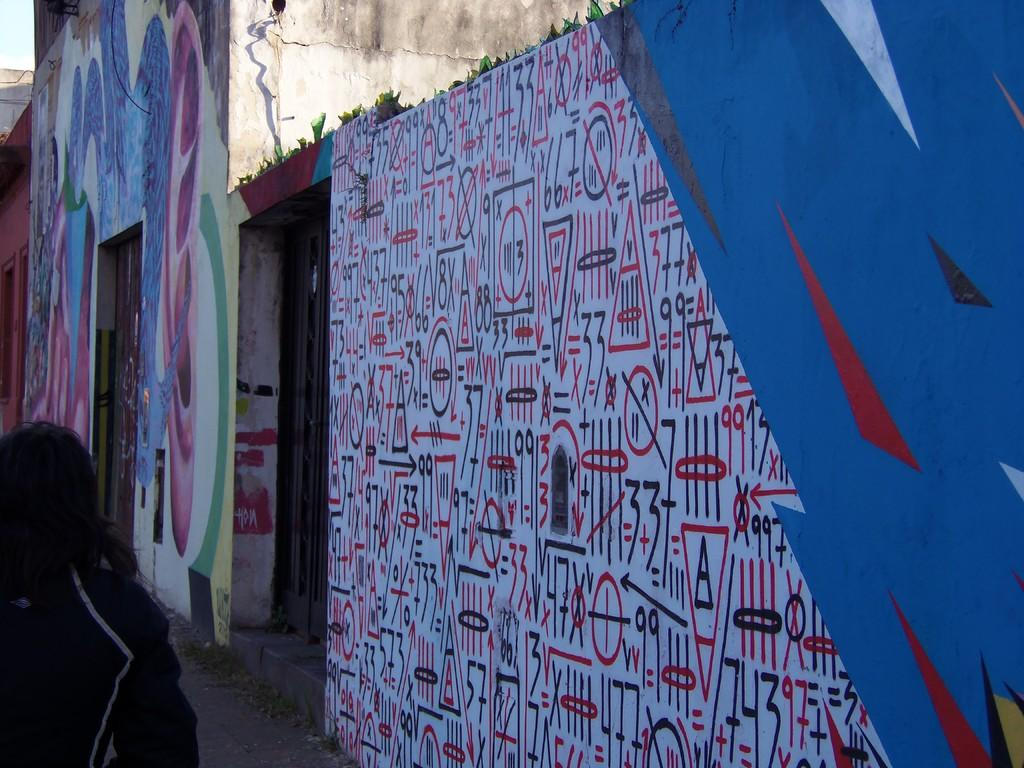What type of structures can be seen in the image? There are buildings in the image. What feature of the buildings is visible in the image? There are doors in the image. Can you describe the person in the image? There is a person on the road in the image. What part of the natural environment is visible in the image? The sky is visible in the top left corner of the image. When was the image taken? The image was taken during the day. What type of crown is the person wearing in the image? There is no crown present in the image; the person is not wearing any headgear. 